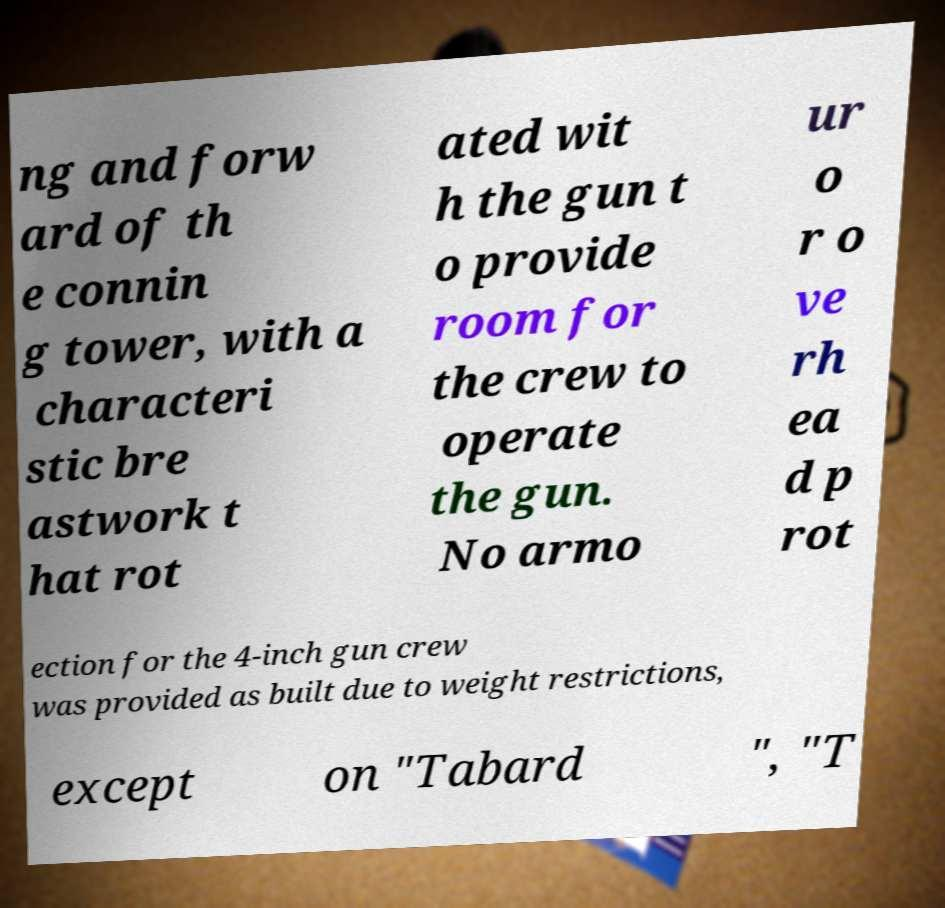Please read and relay the text visible in this image. What does it say? ng and forw ard of th e connin g tower, with a characteri stic bre astwork t hat rot ated wit h the gun t o provide room for the crew to operate the gun. No armo ur o r o ve rh ea d p rot ection for the 4-inch gun crew was provided as built due to weight restrictions, except on "Tabard ", "T 